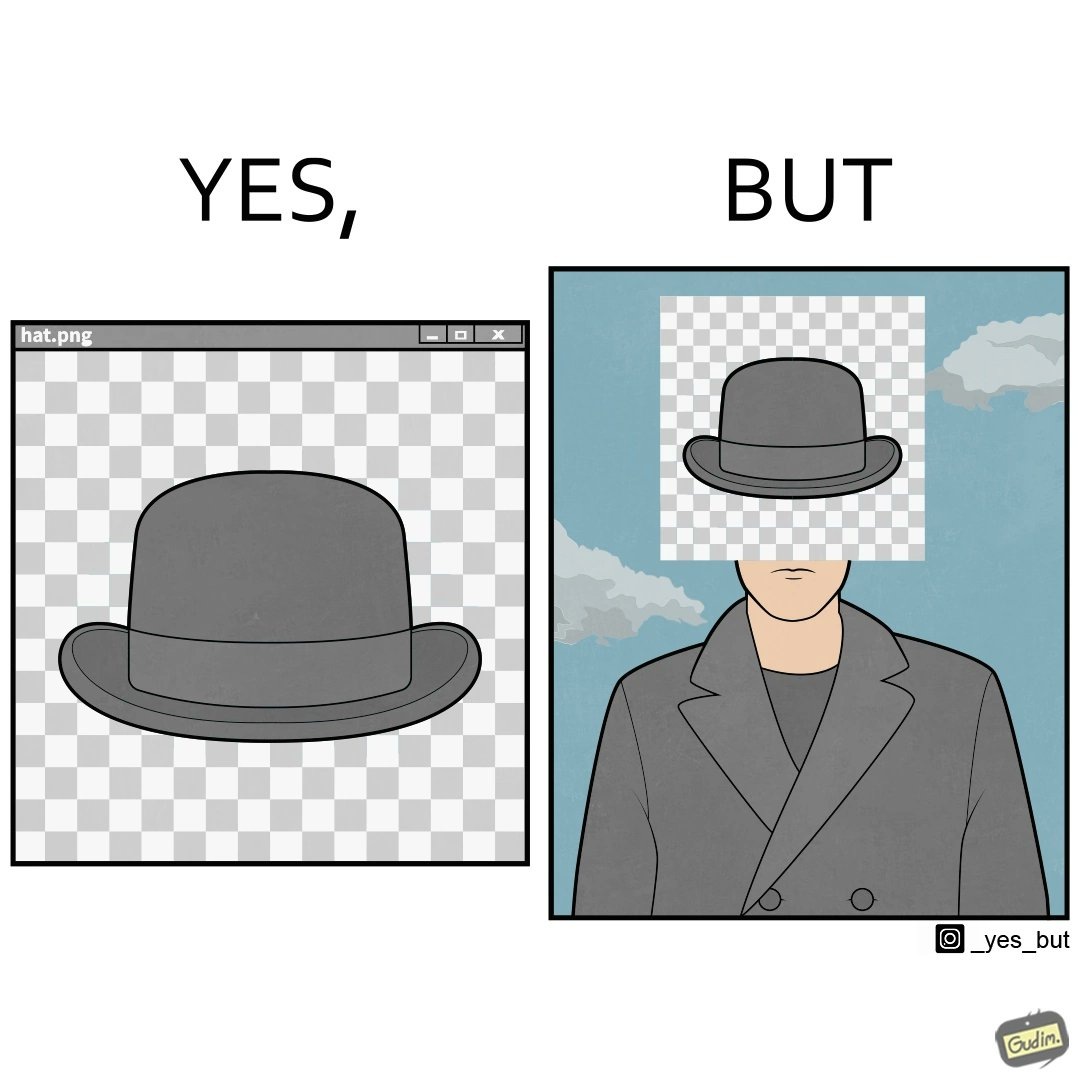What is shown in this image? The images are funny since the .png image of the hat is supposed to have a transparent background but when the image is used for editing a mans picture it is seen that the background is not actually transparent and it ends up covering the face of the man in the other picture. 